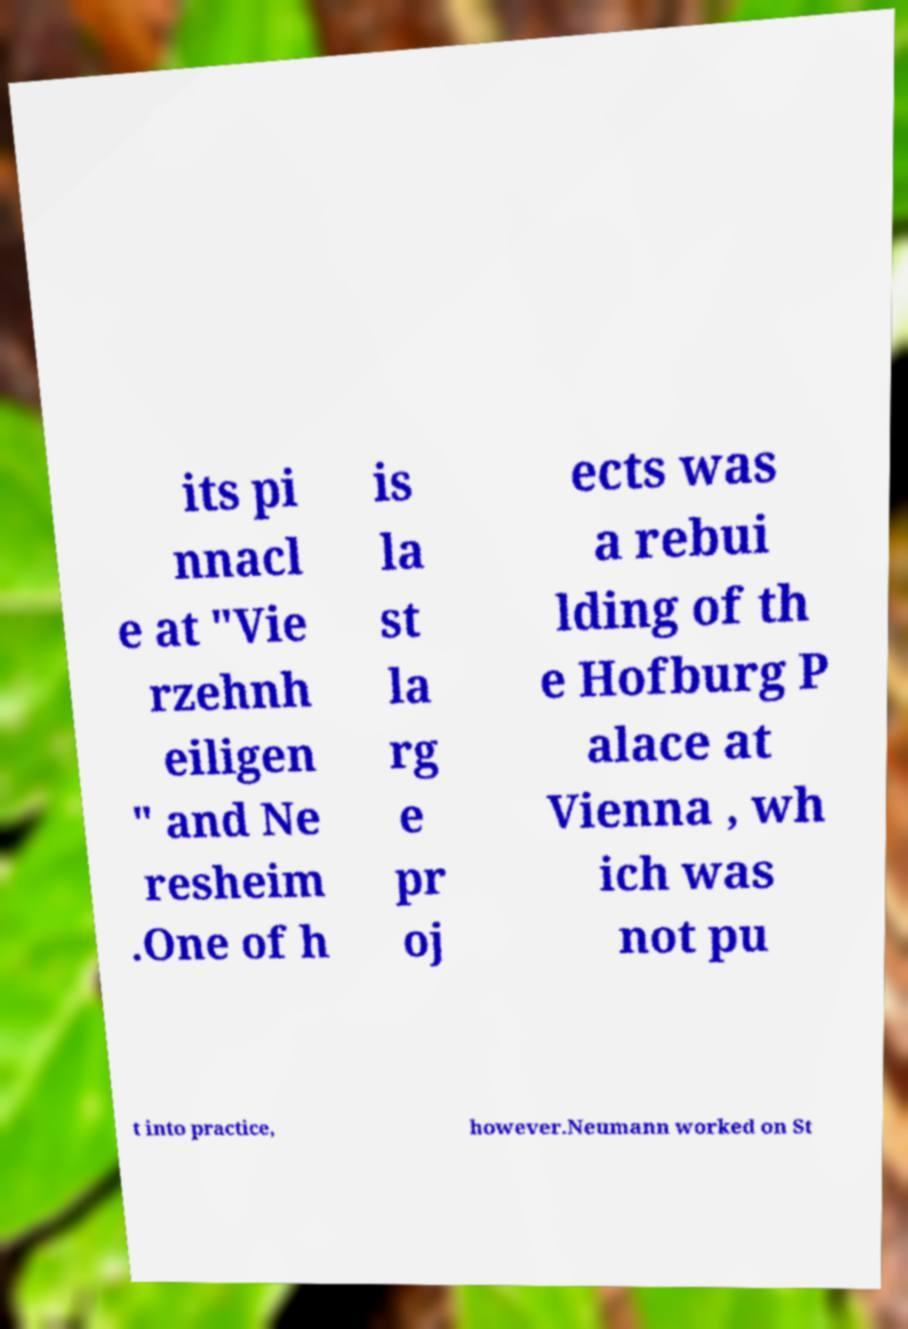Please read and relay the text visible in this image. What does it say? its pi nnacl e at "Vie rzehnh eiligen " and Ne resheim .One of h is la st la rg e pr oj ects was a rebui lding of th e Hofburg P alace at Vienna , wh ich was not pu t into practice, however.Neumann worked on St 